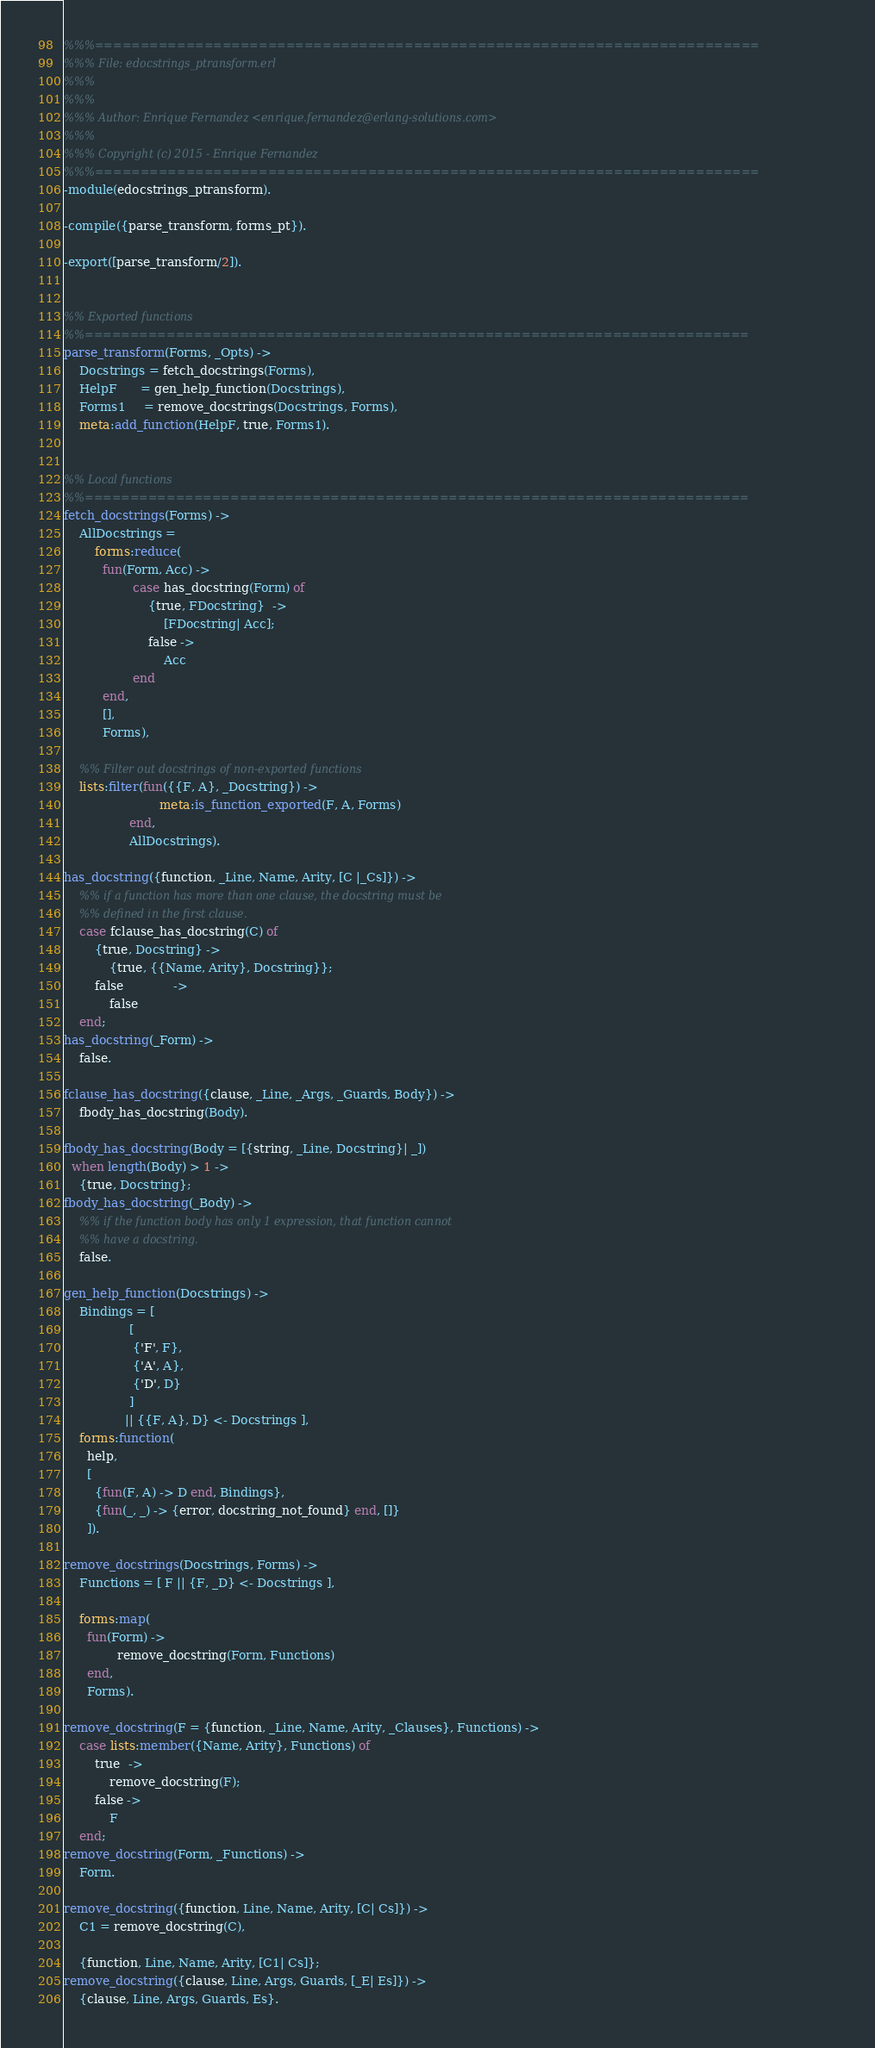Convert code to text. <code><loc_0><loc_0><loc_500><loc_500><_Erlang_>%%%=========================================================================
%%% File: edocstrings_ptransform.erl
%%%
%%%
%%% Author: Enrique Fernandez <enrique.fernandez@erlang-solutions.com>
%%%
%%% Copyright (c) 2015 - Enrique Fernandez
%%%=========================================================================
-module(edocstrings_ptransform).

-compile({parse_transform, forms_pt}).

-export([parse_transform/2]).


%% Exported functions
%%=========================================================================
parse_transform(Forms, _Opts) ->
    Docstrings = fetch_docstrings(Forms),
    HelpF      = gen_help_function(Docstrings),
    Forms1     = remove_docstrings(Docstrings, Forms),
    meta:add_function(HelpF, true, Forms1).


%% Local functions
%%=========================================================================
fetch_docstrings(Forms) ->
    AllDocstrings =
        forms:reduce(
          fun(Form, Acc) ->
                  case has_docstring(Form) of
                      {true, FDocstring}  ->
                          [FDocstring| Acc];
                      false ->
                          Acc
                  end
          end,
          [],
          Forms),

    %% Filter out docstrings of non-exported functions
    lists:filter(fun({{F, A}, _Docstring}) ->
                         meta:is_function_exported(F, A, Forms)
                 end,
                 AllDocstrings).

has_docstring({function, _Line, Name, Arity, [C |_Cs]}) ->
    %% if a function has more than one clause, the docstring must be
    %% defined in the first clause.
    case fclause_has_docstring(C) of
        {true, Docstring} ->
            {true, {{Name, Arity}, Docstring}};
        false             ->
            false
    end;
has_docstring(_Form) ->
    false.

fclause_has_docstring({clause, _Line, _Args, _Guards, Body}) ->
    fbody_has_docstring(Body).

fbody_has_docstring(Body = [{string, _Line, Docstring}| _])
  when length(Body) > 1 ->
    {true, Docstring};
fbody_has_docstring(_Body) ->
    %% if the function body has only 1 expression, that function cannot
    %% have a docstring.
    false.

gen_help_function(Docstrings) ->
    Bindings = [
                 [
                  {'F', F},
                  {'A', A},
                  {'D', D}
                 ]
                || {{F, A}, D} <- Docstrings ],
    forms:function(
      help,
      [
        {fun(F, A) -> D end, Bindings},
        {fun(_, _) -> {error, docstring_not_found} end, []}
      ]).

remove_docstrings(Docstrings, Forms) ->
    Functions = [ F || {F, _D} <- Docstrings ],

    forms:map(
      fun(Form) ->
              remove_docstring(Form, Functions)
      end,
      Forms).

remove_docstring(F = {function, _Line, Name, Arity, _Clauses}, Functions) ->
    case lists:member({Name, Arity}, Functions) of
        true  ->
            remove_docstring(F);
        false ->
            F
    end;
remove_docstring(Form, _Functions) ->
    Form.

remove_docstring({function, Line, Name, Arity, [C| Cs]}) ->
    C1 = remove_docstring(C),

    {function, Line, Name, Arity, [C1| Cs]};
remove_docstring({clause, Line, Args, Guards, [_E| Es]}) ->
    {clause, Line, Args, Guards, Es}.
</code> 